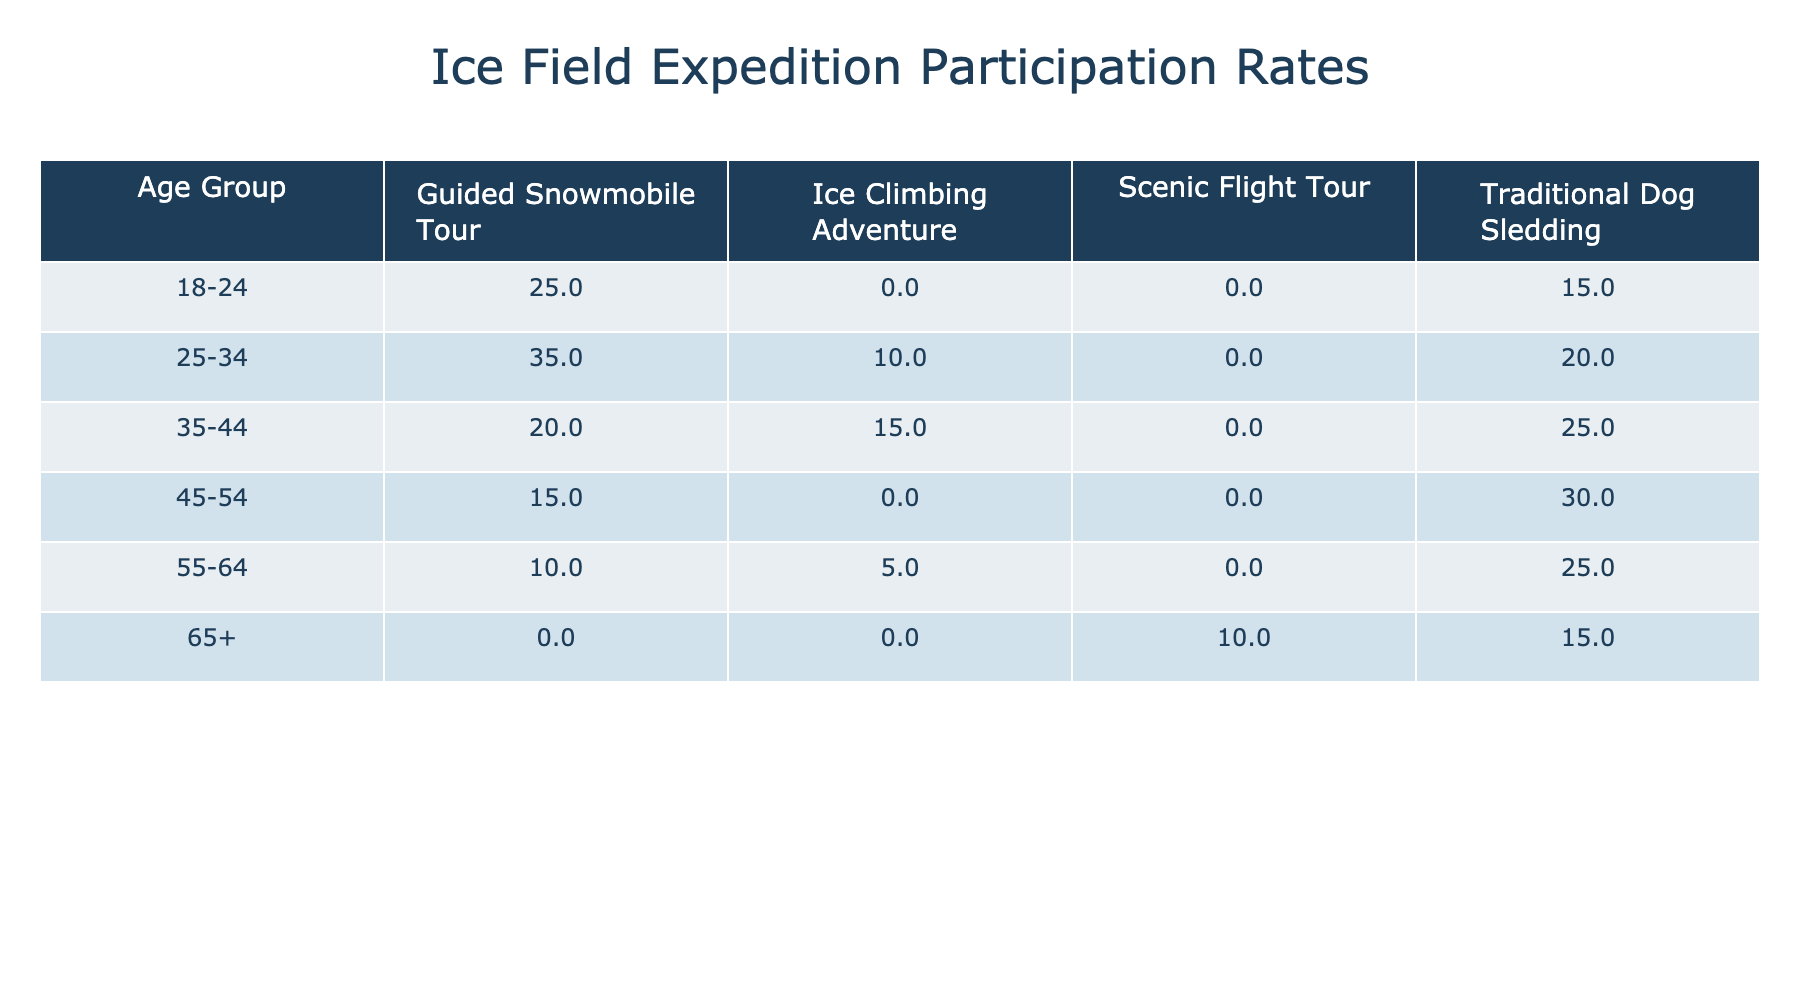What is the participation rate for 25-34 age group in Guided Snowmobile Tour? In the table, locate the row for the age group 25-34 and the column for Guided Snowmobile Tour. The value at this intersection is 35%.
Answer: 35% Which tour type has the highest participation rate among 55-64 age group? Look at the participation rates for the 55-64 age group across all tour types. The values are 10% for Guided Snowmobile Tour, 25% for Traditional Dog Sledding, and 5% for Ice Climbing Adventure. The highest among these is 25% for Traditional Dog Sledding.
Answer: Traditional Dog Sledding Is the participation rate for Ice Climbing Adventure greater than 10% for age groups 45-54 and 55-64 combined? For age group 45-54, the participation rate in Ice Climbing Adventure is 0%, and for age group 55-64, it is 5%. Adding these together gives 0% + 5% = 5%, which is not greater than 10%.
Answer: No What is the average participation rate for Guided Snowmobile Tour across all age groups? The participation rates for Guided Snowmobile Tour are 25% (18-24), 35% (25-34), 20% (35-44), 15% (45-54), and 10% (55-64). Adding these gives 25 + 35 + 20 + 15 + 10 = 105%. There are 5 data points, so dividing the total by 5 results in an average of 105% / 5 = 21%.
Answer: 21% In which age group is Traditional Dog Sledding the most popular? Examine the participation rates for Traditional Dog Sledding across all age groups: 15% (18-24), 20% (25-34), 25% (35-44), 30% (45-54), 25% (55-64), and 15% (65+). The highest rate is 30% for the 45-54 age group.
Answer: 45-54 Is there a tour type with a 0% participation rate in any age group? Check each tour type across the age groups. Ice Climbing Adventure has a participation rate of 0% for the 45-54 age group, as it is not listed.
Answer: Yes What is the total participation rate for all tour types in the 65+ age group? For the 65+ age group, there are participation rates of 15% (Traditional Dog Sledding) and 10% (Scenic Flight Tour). Adding these gives 15% + 10% = 25%.
Answer: 25% For which age group is the sum of participation rates in Guided Snowmobile Tour and Ice Climbing Adventure greater than 30%? Calculate the sum for each age group. For 18-24: 25% + 0% = 25%; for 25-34: 35% + 10% = 45%; for 35-44: 20% + 15% = 35%; for 45-54: 15% + 0% = 15%; for 55-64: 10% + 5% = 15%; for 65+: 0% + 0% = 0%. The age groups 25-34 and 35-44 exceed 30%.
Answer: 25-34 and 35-44 